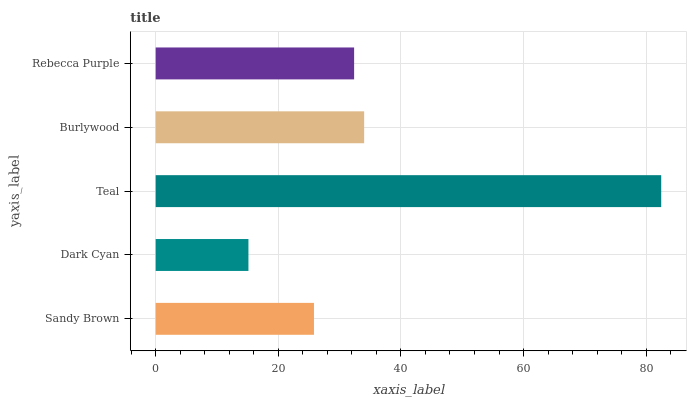Is Dark Cyan the minimum?
Answer yes or no. Yes. Is Teal the maximum?
Answer yes or no. Yes. Is Teal the minimum?
Answer yes or no. No. Is Dark Cyan the maximum?
Answer yes or no. No. Is Teal greater than Dark Cyan?
Answer yes or no. Yes. Is Dark Cyan less than Teal?
Answer yes or no. Yes. Is Dark Cyan greater than Teal?
Answer yes or no. No. Is Teal less than Dark Cyan?
Answer yes or no. No. Is Rebecca Purple the high median?
Answer yes or no. Yes. Is Rebecca Purple the low median?
Answer yes or no. Yes. Is Sandy Brown the high median?
Answer yes or no. No. Is Dark Cyan the low median?
Answer yes or no. No. 